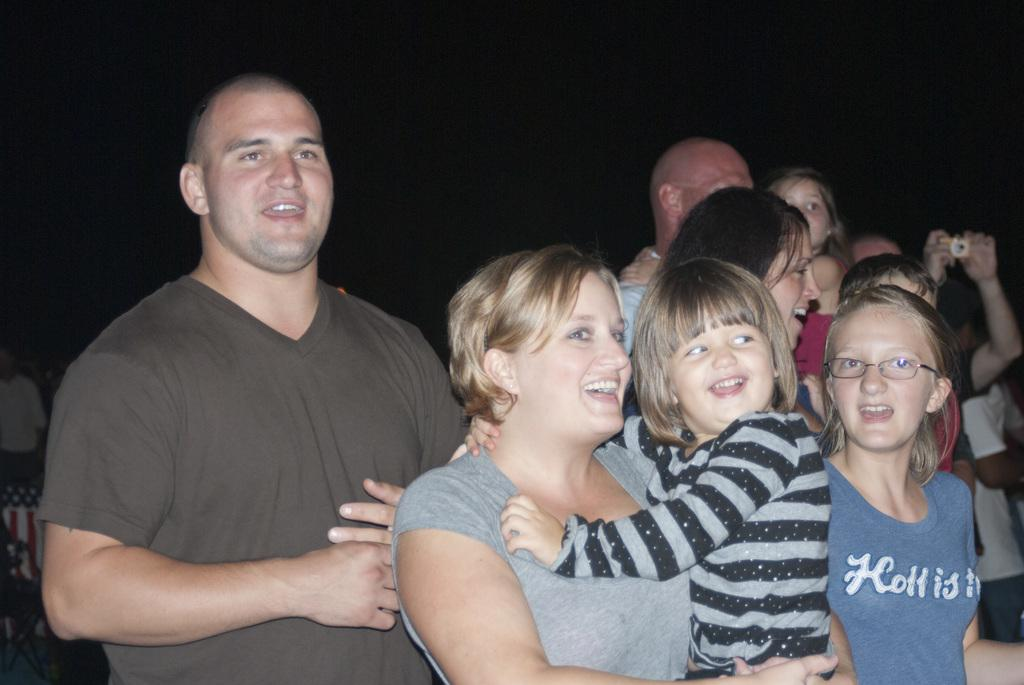What is the main subject of the image? The main subject of the image is a crowd. Where is the crowd located in the image? The crowd is standing on the ground. Is there any snow visible in the image? There is no mention of snow in the provided facts, so we cannot determine if it is present in the image. 